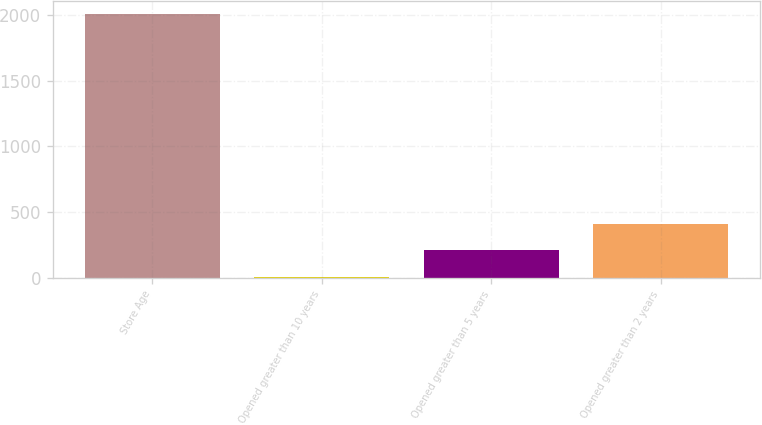Convert chart. <chart><loc_0><loc_0><loc_500><loc_500><bar_chart><fcel>Store Age<fcel>Opened greater than 10 years<fcel>Opened greater than 5 years<fcel>Opened greater than 2 years<nl><fcel>2012<fcel>8.1<fcel>208.49<fcel>408.88<nl></chart> 